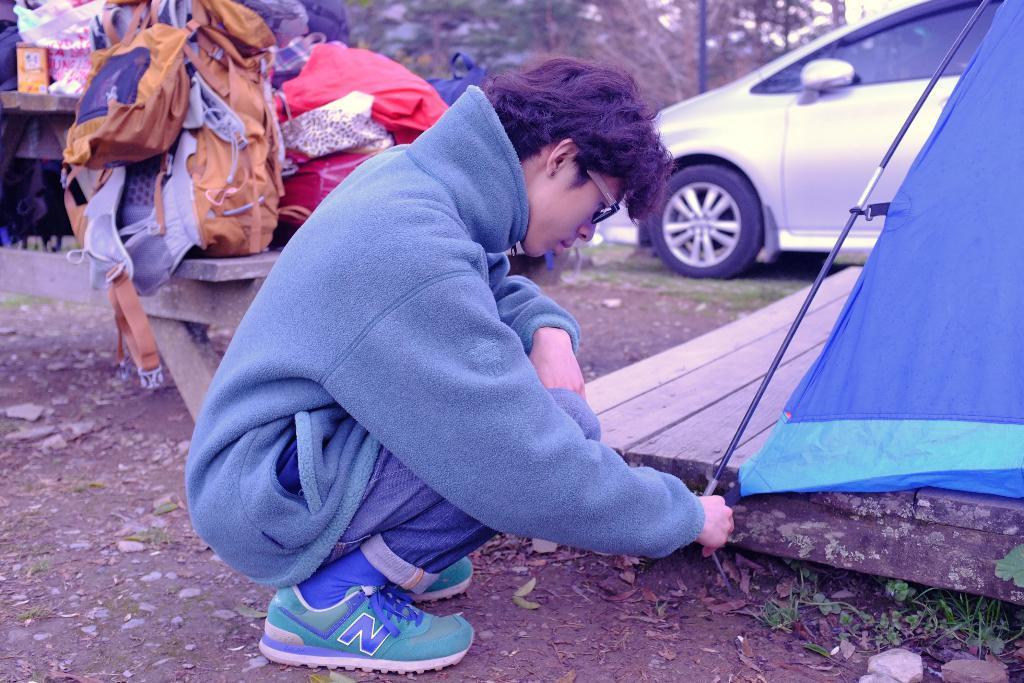Describe this image in one or two sentences. In this picture there is a boy wearing blue hoodie is sitting on the ground and fixing the canopy. Behind there is a white car parked in the ground. In the background there are some bags on the table. 